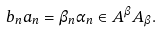Convert formula to latex. <formula><loc_0><loc_0><loc_500><loc_500>b _ { n } a _ { n } = \beta _ { n } \alpha _ { n } \in A ^ { \beta } A _ { \beta } .</formula> 